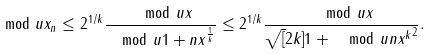Convert formula to latex. <formula><loc_0><loc_0><loc_500><loc_500>\mod u { x _ { n } } \leq 2 ^ { 1 / k } \frac { \mod u x } { \mod u { 1 + n x } ^ { \frac { 1 } { k } } } \leq 2 ^ { 1 / k } \frac { \mod u x } { \sqrt { [ } 2 k ] { 1 + \mod u { n x ^ { k } } ^ { 2 } } } .</formula> 